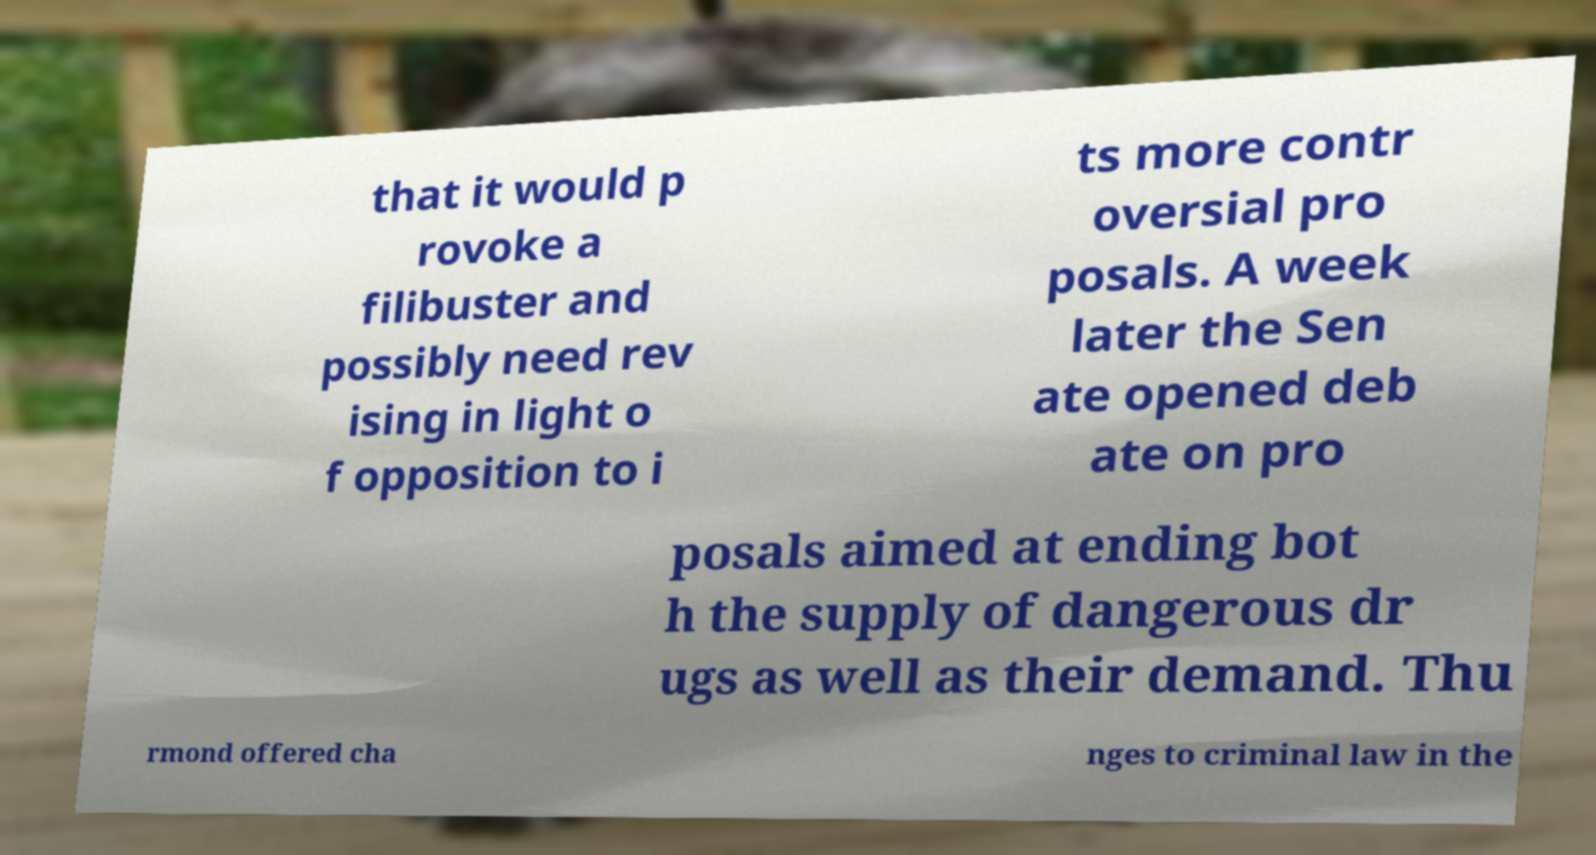Please read and relay the text visible in this image. What does it say? that it would p rovoke a filibuster and possibly need rev ising in light o f opposition to i ts more contr oversial pro posals. A week later the Sen ate opened deb ate on pro posals aimed at ending bot h the supply of dangerous dr ugs as well as their demand. Thu rmond offered cha nges to criminal law in the 